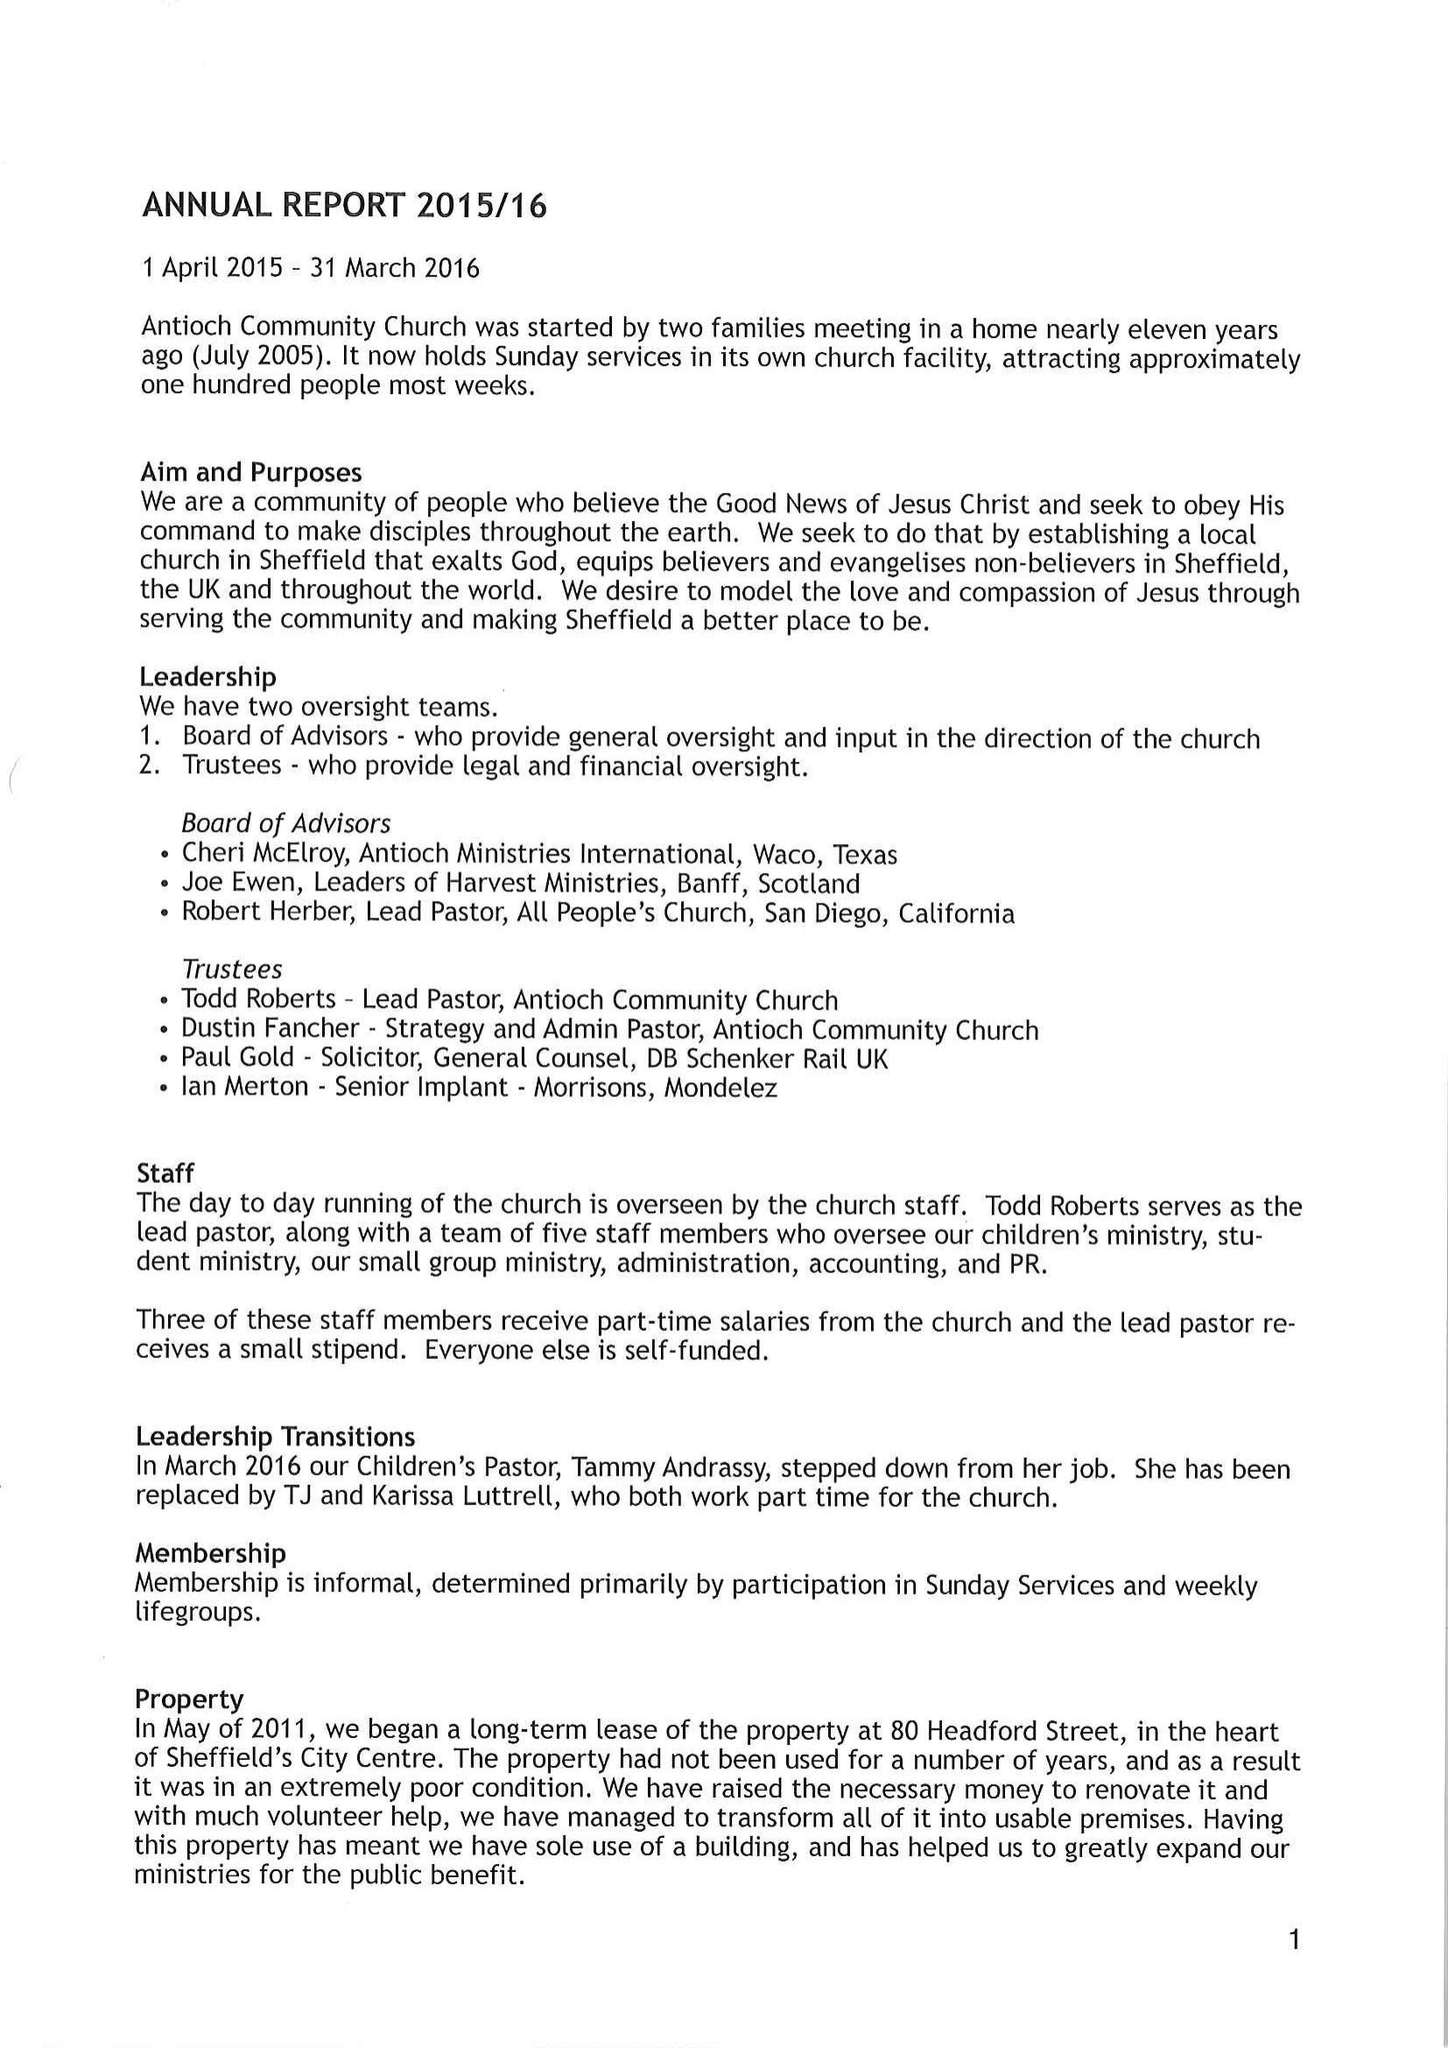What is the value for the charity_number?
Answer the question using a single word or phrase. None 